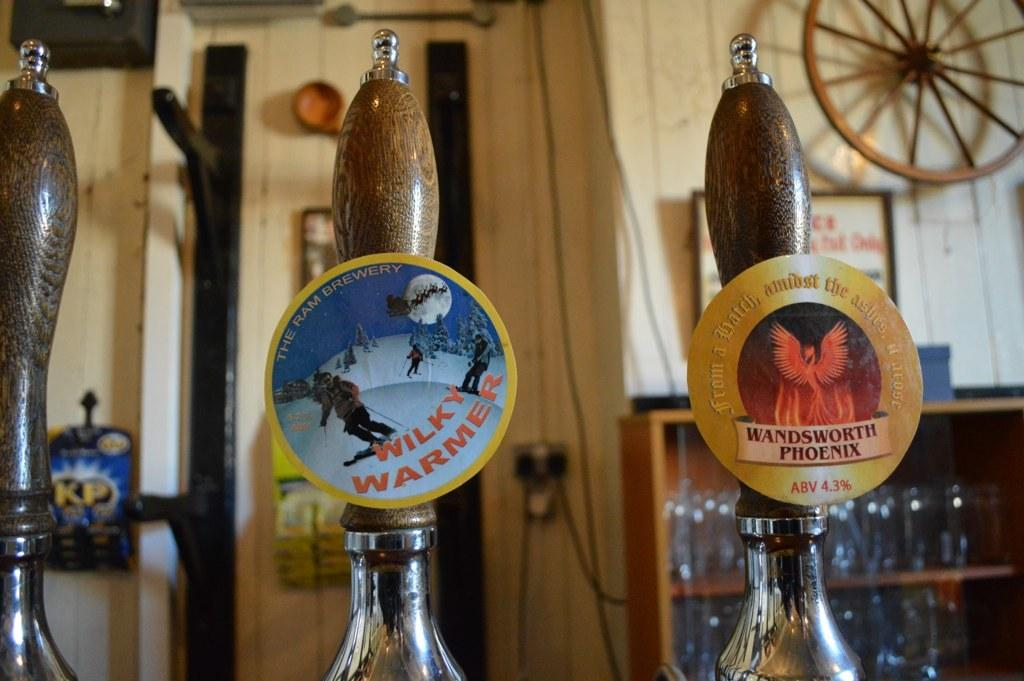<image>
Give a short and clear explanation of the subsequent image. Beer pulls for Wilky Warmer and Wandsworth Phoenix are shown. 